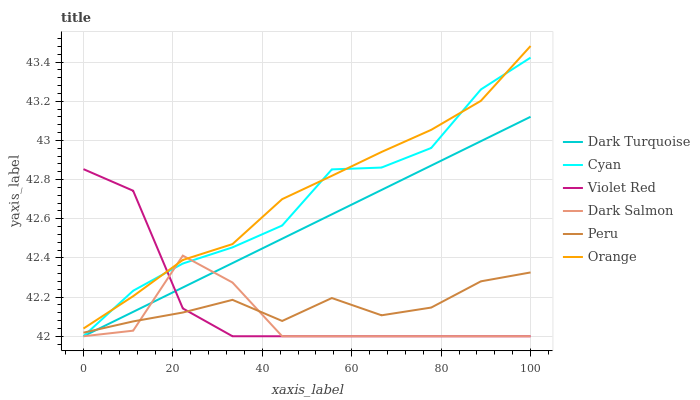Does Dark Salmon have the minimum area under the curve?
Answer yes or no. Yes. Does Orange have the maximum area under the curve?
Answer yes or no. Yes. Does Dark Turquoise have the minimum area under the curve?
Answer yes or no. No. Does Dark Turquoise have the maximum area under the curve?
Answer yes or no. No. Is Dark Turquoise the smoothest?
Answer yes or no. Yes. Is Dark Salmon the roughest?
Answer yes or no. Yes. Is Dark Salmon the smoothest?
Answer yes or no. No. Is Dark Turquoise the roughest?
Answer yes or no. No. Does Violet Red have the lowest value?
Answer yes or no. Yes. Does Peru have the lowest value?
Answer yes or no. No. Does Orange have the highest value?
Answer yes or no. Yes. Does Dark Turquoise have the highest value?
Answer yes or no. No. Is Peru less than Orange?
Answer yes or no. Yes. Is Orange greater than Dark Turquoise?
Answer yes or no. Yes. Does Peru intersect Dark Turquoise?
Answer yes or no. Yes. Is Peru less than Dark Turquoise?
Answer yes or no. No. Is Peru greater than Dark Turquoise?
Answer yes or no. No. Does Peru intersect Orange?
Answer yes or no. No. 